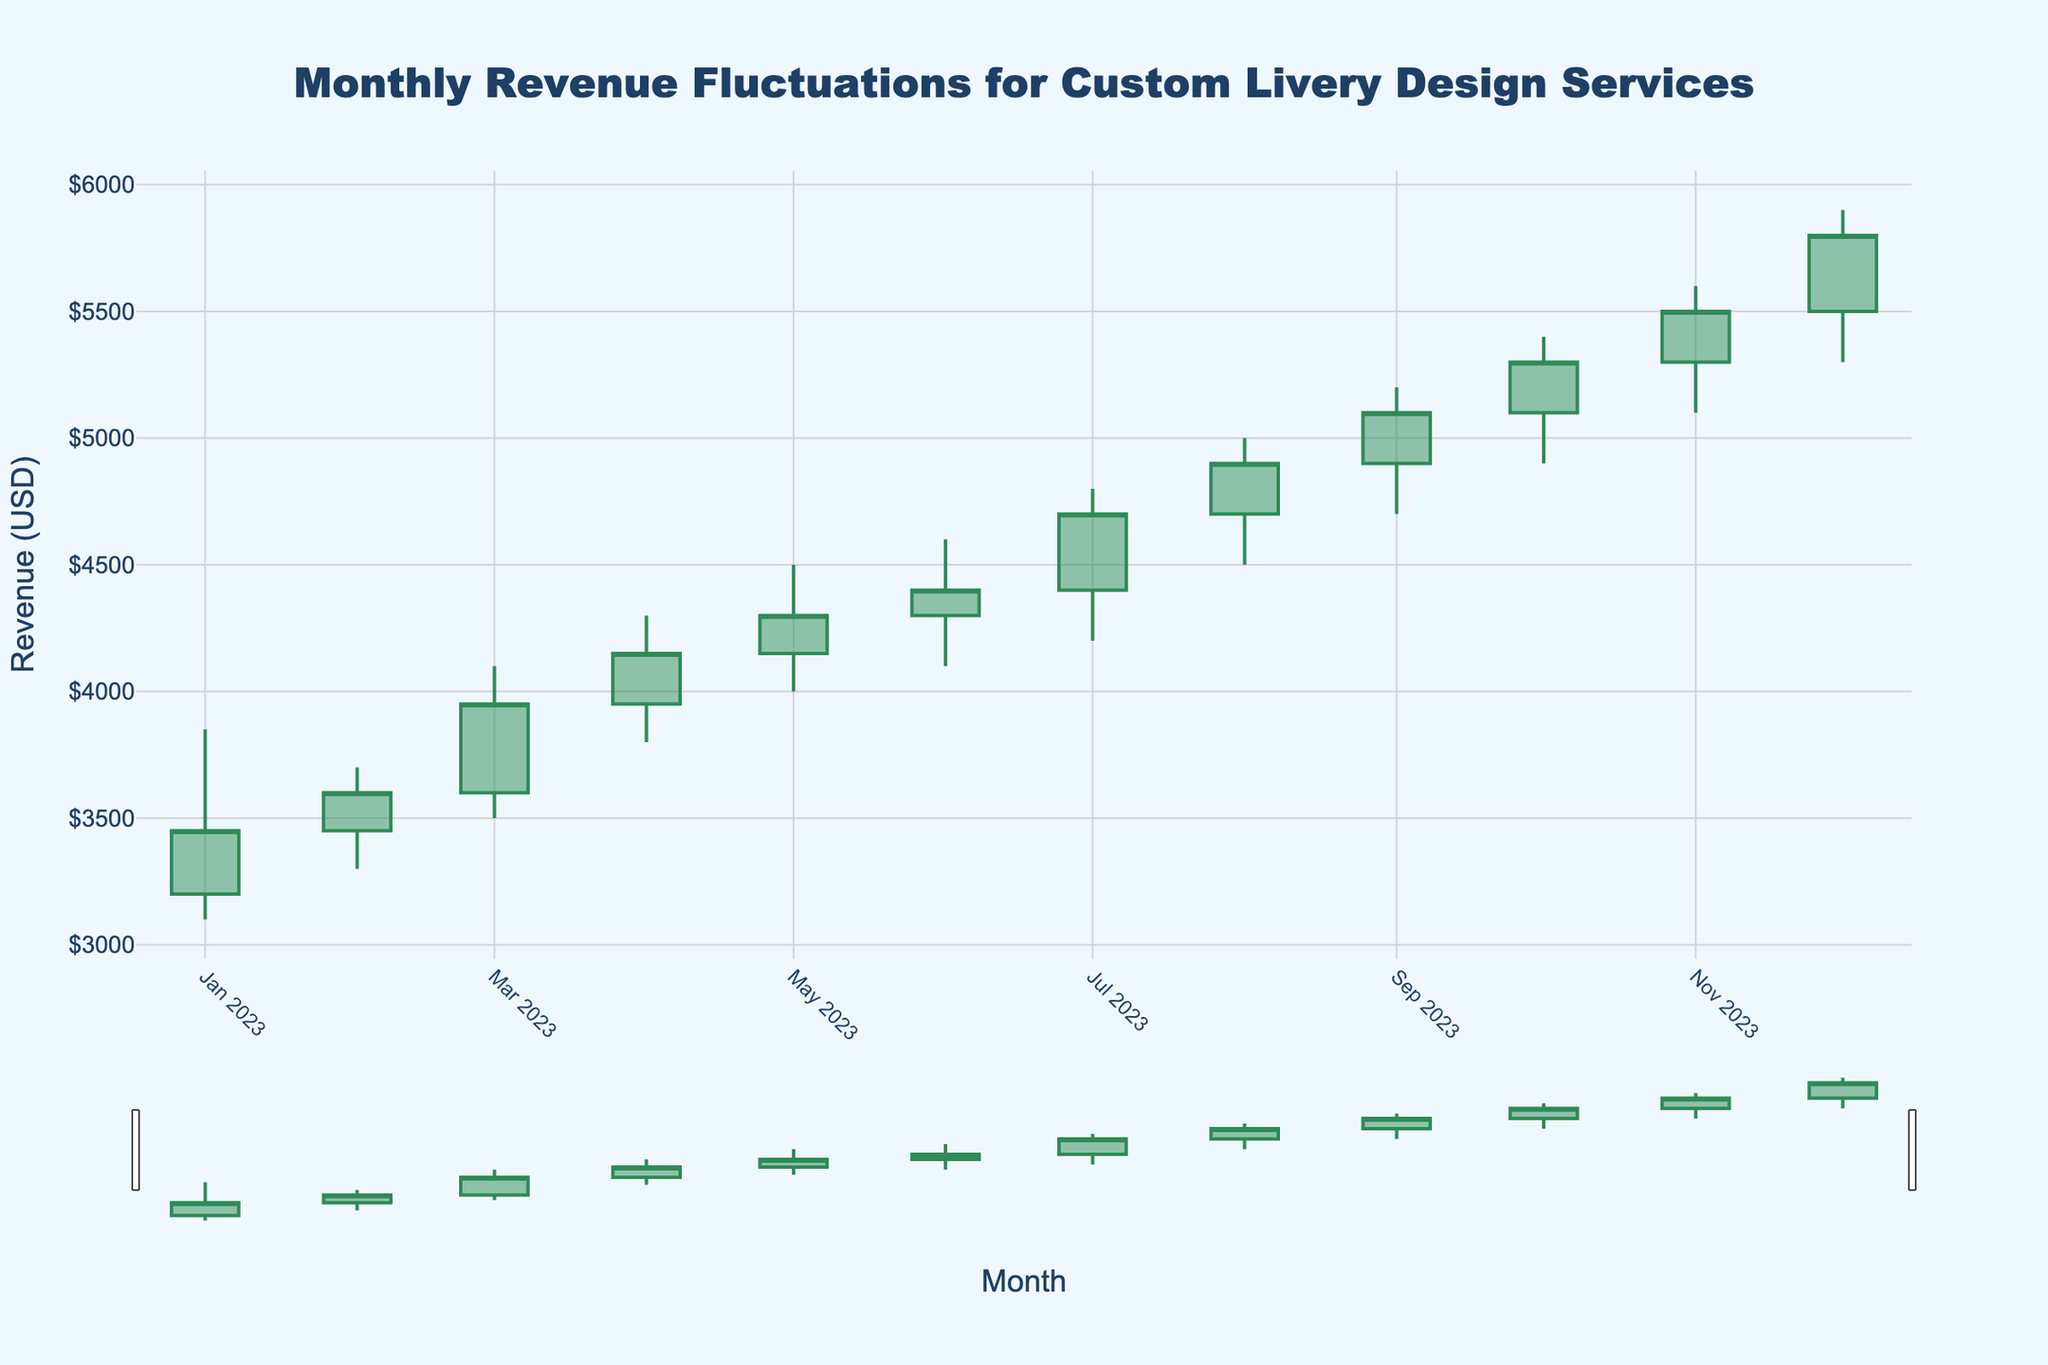What is the title of the chart? The title of the chart is displayed at the top of the figure. It reads "Monthly Revenue Fluctuations for Custom Livery Design Services".
Answer: Monthly Revenue Fluctuations for Custom Livery Design Services What are the colors used for increasing and decreasing revenue lines in the chart? The increasing lines are colored in sea green, and the decreasing lines are colored in dark red.
Answer: Sea green and dark red Which month had the highest revenue close value? To find the month with the highest revenue close value, look at the 'Close' values for each month. December 2023 has the highest close value at $5800.
Answer: December 2023 In which month did the revenue open at a value of $3200? Look at the 'Open' values for each month. January 2023 has the open value of $3200.
Answer: January 2023 What is the total range of the high values for the year 2023? The highest 'High' value is $5900 (December 2023) and the lowest 'High' value is $3700 (February 2023). The range is calculated as $5900 - $3700 = $2200.
Answer: $2200 Between August 2023 and October 2023, which month showed the highest low value? Compare the 'Low' values for August 2023 ($4500), September 2023 ($4700), and October 2023 ($4900). October 2023 has the highest low value at $4900.
Answer: October 2023 How much did the revenue close value increase from July 2023 to August 2023? The close value in July 2023 is $4700 and in August 2023 it is $4900. The increase is $4900 - $4700 = $200.
Answer: $200 Which month has the smallest difference between the high and low revenue values? Calculate the difference between 'High' and 'Low' for each month. February 2023 has the smallest difference: $3700 - $3300 = $400.
Answer: February 2023 Across the entire year, how many months showed a decrease in the closing revenue compared to the opening revenue? Check the 'Close' and 'Open' values for each month to see if 'Close' is less than 'Open'. This happens in January 2023, March 2023, and November 2023.
Answer: 3 months 